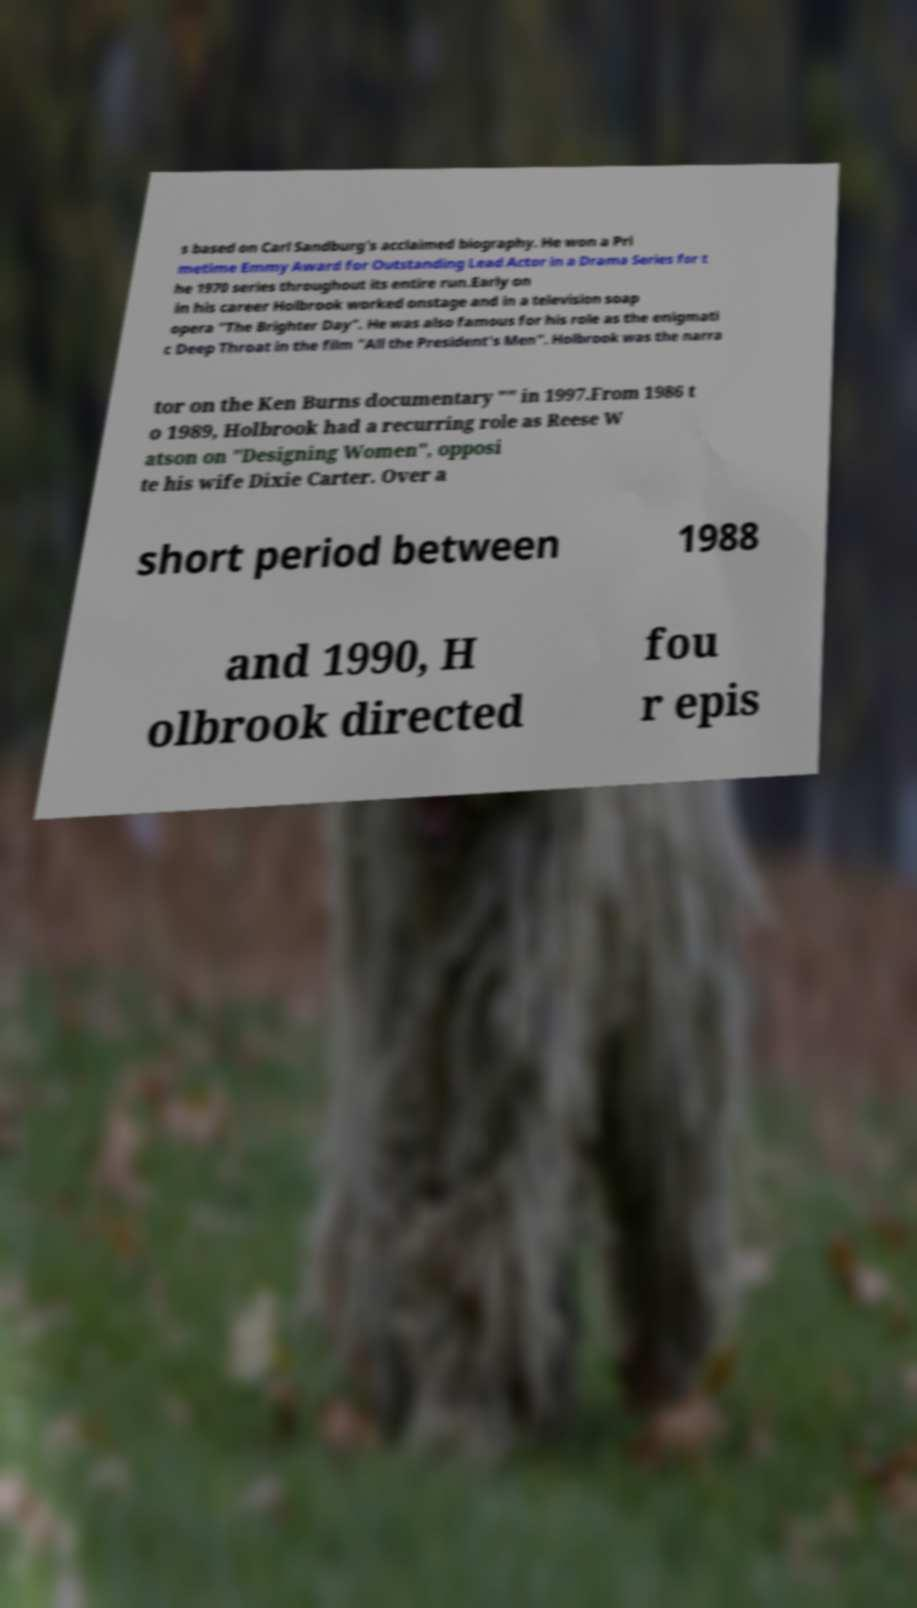What messages or text are displayed in this image? I need them in a readable, typed format. s based on Carl Sandburg's acclaimed biography. He won a Pri metime Emmy Award for Outstanding Lead Actor in a Drama Series for t he 1970 series throughout its entire run.Early on in his career Holbrook worked onstage and in a television soap opera "The Brighter Day". He was also famous for his role as the enigmati c Deep Throat in the film "All the President's Men". Holbrook was the narra tor on the Ken Burns documentary "" in 1997.From 1986 t o 1989, Holbrook had a recurring role as Reese W atson on "Designing Women", opposi te his wife Dixie Carter. Over a short period between 1988 and 1990, H olbrook directed fou r epis 